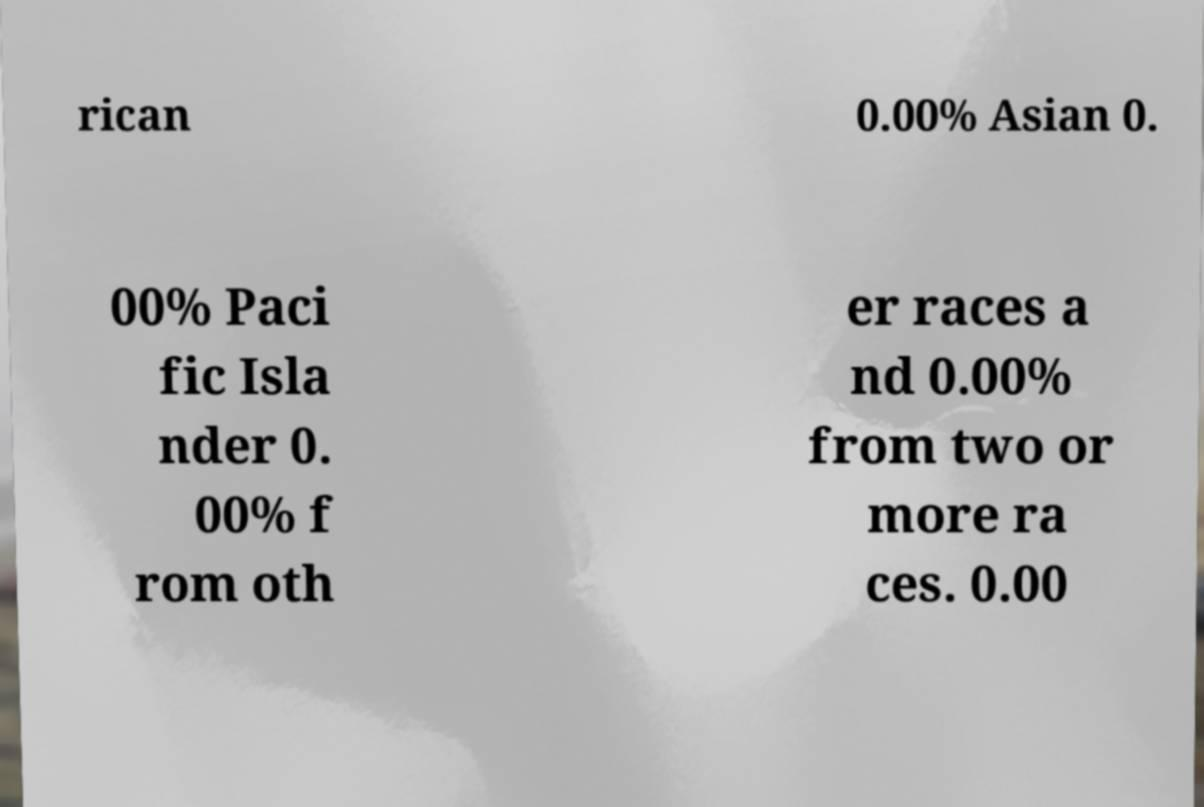Can you accurately transcribe the text from the provided image for me? rican 0.00% Asian 0. 00% Paci fic Isla nder 0. 00% f rom oth er races a nd 0.00% from two or more ra ces. 0.00 